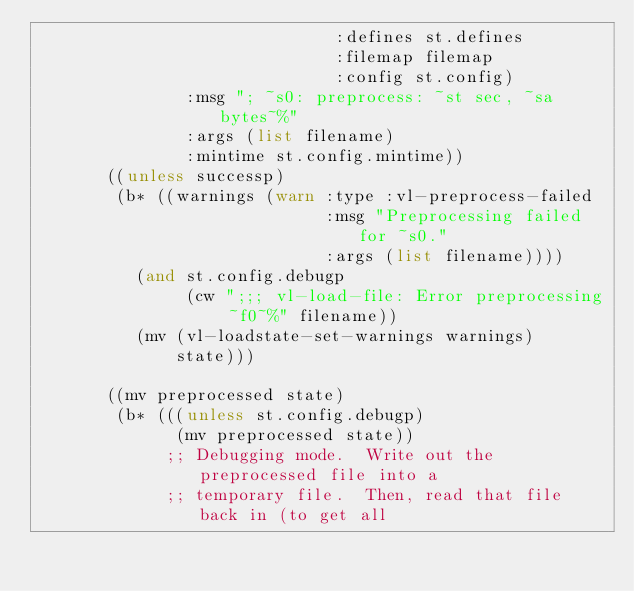<code> <loc_0><loc_0><loc_500><loc_500><_Lisp_>                              :defines st.defines
                              :filemap filemap
                              :config st.config)
               :msg "; ~s0: preprocess: ~st sec, ~sa bytes~%"
               :args (list filename)
               :mintime st.config.mintime))
       ((unless successp)
        (b* ((warnings (warn :type :vl-preprocess-failed
                             :msg "Preprocessing failed for ~s0."
                             :args (list filename))))
          (and st.config.debugp
               (cw ";;; vl-load-file: Error preprocessing ~f0~%" filename))
          (mv (vl-loadstate-set-warnings warnings)
              state)))

       ((mv preprocessed state)
        (b* (((unless st.config.debugp)
              (mv preprocessed state))
             ;; Debugging mode.  Write out the preprocessed file into a
             ;; temporary file.  Then, read that file back in (to get all</code> 